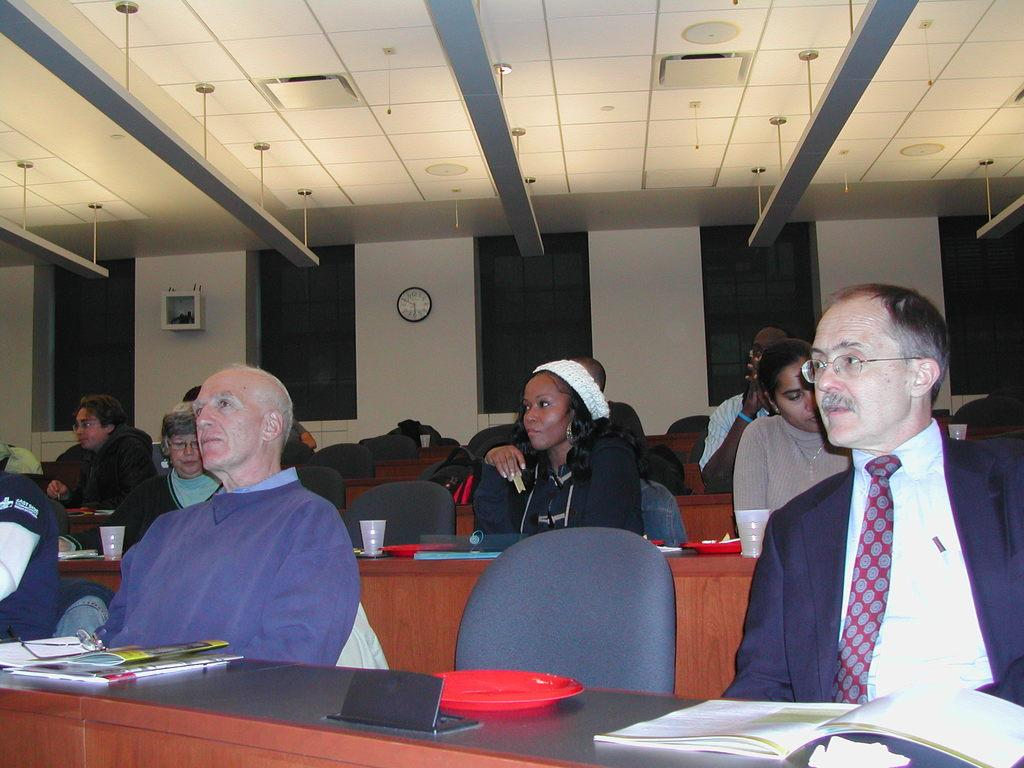What are the people in the image doing? The people in the image are sitting on chairs. What can be seen on the table or surface in front of the people? There are books and cups visible in the image. What other objects can be seen in the image? There are other objects present in the image, but their specific details are not mentioned in the provided facts. What can be seen in the background of the image? There is a wall, a clock, and a roof visible in the background of the image. Are there any other objects in the background of the image? Yes, there are other objects in the background of the image, as mentioned in the provided facts. What advice is the person in the image giving to the driver? There is no person giving advice to a driver in the image, as there is no mention of a driver or any advice-giving situation. 